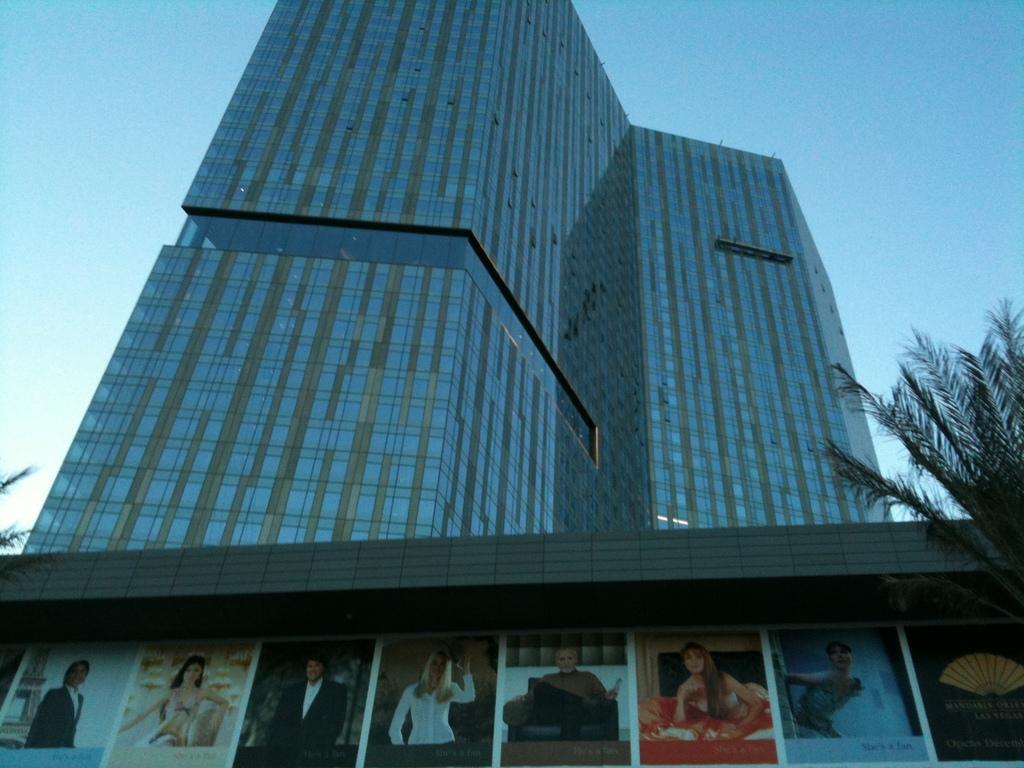In one or two sentences, can you explain what this image depicts? In the foreground we can see some banners with photos and text. In the background, we can see a building, group of plants and the sky. 